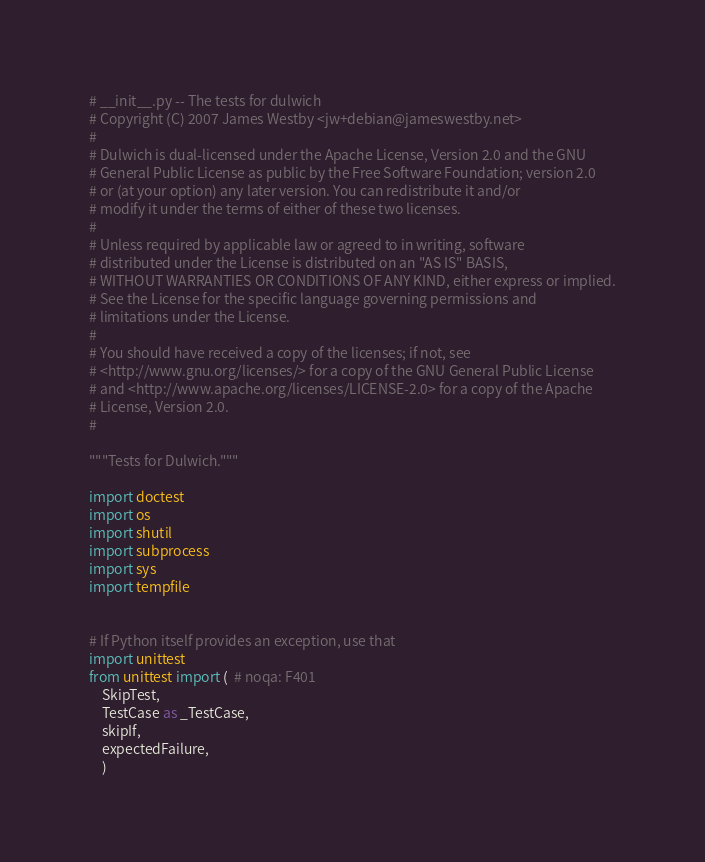Convert code to text. <code><loc_0><loc_0><loc_500><loc_500><_Python_># __init__.py -- The tests for dulwich
# Copyright (C) 2007 James Westby <jw+debian@jameswestby.net>
#
# Dulwich is dual-licensed under the Apache License, Version 2.0 and the GNU
# General Public License as public by the Free Software Foundation; version 2.0
# or (at your option) any later version. You can redistribute it and/or
# modify it under the terms of either of these two licenses.
#
# Unless required by applicable law or agreed to in writing, software
# distributed under the License is distributed on an "AS IS" BASIS,
# WITHOUT WARRANTIES OR CONDITIONS OF ANY KIND, either express or implied.
# See the License for the specific language governing permissions and
# limitations under the License.
#
# You should have received a copy of the licenses; if not, see
# <http://www.gnu.org/licenses/> for a copy of the GNU General Public License
# and <http://www.apache.org/licenses/LICENSE-2.0> for a copy of the Apache
# License, Version 2.0.
#

"""Tests for Dulwich."""

import doctest
import os
import shutil
import subprocess
import sys
import tempfile


# If Python itself provides an exception, use that
import unittest
from unittest import (  # noqa: F401
    SkipTest,
    TestCase as _TestCase,
    skipIf,
    expectedFailure,
    )

</code> 